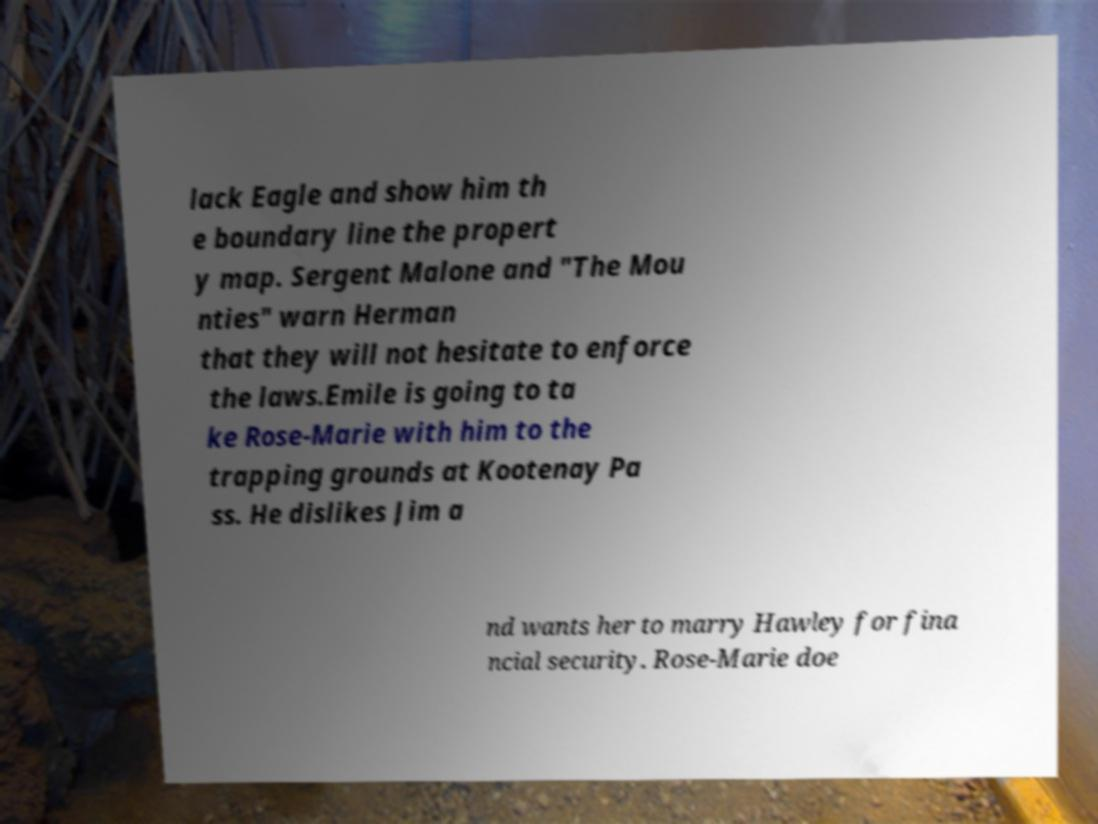There's text embedded in this image that I need extracted. Can you transcribe it verbatim? lack Eagle and show him th e boundary line the propert y map. Sergent Malone and "The Mou nties" warn Herman that they will not hesitate to enforce the laws.Emile is going to ta ke Rose-Marie with him to the trapping grounds at Kootenay Pa ss. He dislikes Jim a nd wants her to marry Hawley for fina ncial security. Rose-Marie doe 